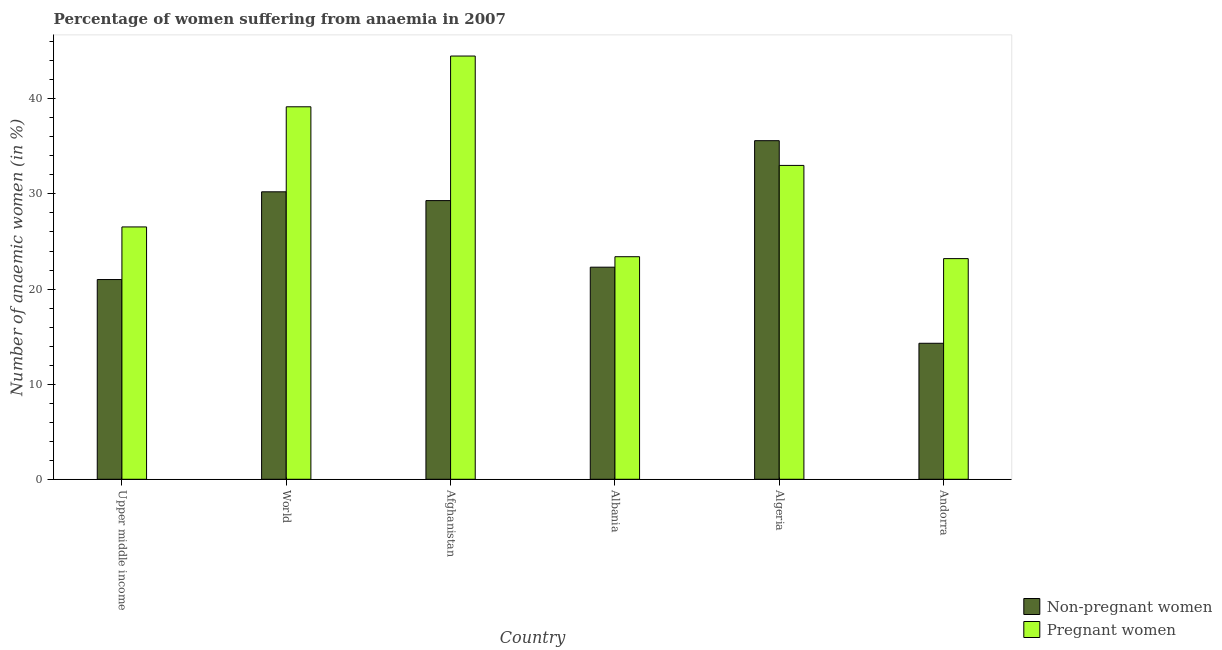How many different coloured bars are there?
Ensure brevity in your answer.  2. How many groups of bars are there?
Keep it short and to the point. 6. How many bars are there on the 4th tick from the right?
Offer a very short reply. 2. What is the label of the 6th group of bars from the left?
Provide a short and direct response. Andorra. What is the percentage of pregnant anaemic women in Afghanistan?
Provide a succinct answer. 44.5. Across all countries, what is the maximum percentage of non-pregnant anaemic women?
Ensure brevity in your answer.  35.6. Across all countries, what is the minimum percentage of non-pregnant anaemic women?
Keep it short and to the point. 14.3. In which country was the percentage of non-pregnant anaemic women maximum?
Your answer should be compact. Algeria. In which country was the percentage of pregnant anaemic women minimum?
Offer a very short reply. Andorra. What is the total percentage of pregnant anaemic women in the graph?
Make the answer very short. 189.8. What is the difference between the percentage of pregnant anaemic women in Afghanistan and that in Andorra?
Your answer should be compact. 21.3. What is the difference between the percentage of non-pregnant anaemic women in Algeria and the percentage of pregnant anaemic women in World?
Offer a terse response. -3.56. What is the average percentage of pregnant anaemic women per country?
Your answer should be very brief. 31.63. In how many countries, is the percentage of pregnant anaemic women greater than 28 %?
Your response must be concise. 3. What is the ratio of the percentage of pregnant anaemic women in Upper middle income to that in World?
Offer a very short reply. 0.68. Is the difference between the percentage of pregnant anaemic women in Andorra and Upper middle income greater than the difference between the percentage of non-pregnant anaemic women in Andorra and Upper middle income?
Offer a terse response. Yes. What is the difference between the highest and the second highest percentage of pregnant anaemic women?
Provide a succinct answer. 5.34. What is the difference between the highest and the lowest percentage of pregnant anaemic women?
Offer a terse response. 21.3. What does the 1st bar from the left in World represents?
Provide a succinct answer. Non-pregnant women. What does the 1st bar from the right in Andorra represents?
Make the answer very short. Pregnant women. How many countries are there in the graph?
Provide a succinct answer. 6. What is the difference between two consecutive major ticks on the Y-axis?
Offer a very short reply. 10. Are the values on the major ticks of Y-axis written in scientific E-notation?
Offer a terse response. No. Does the graph contain any zero values?
Give a very brief answer. No. How many legend labels are there?
Provide a succinct answer. 2. What is the title of the graph?
Offer a terse response. Percentage of women suffering from anaemia in 2007. Does "Methane emissions" appear as one of the legend labels in the graph?
Ensure brevity in your answer.  No. What is the label or title of the X-axis?
Provide a succinct answer. Country. What is the label or title of the Y-axis?
Give a very brief answer. Number of anaemic women (in %). What is the Number of anaemic women (in %) in Non-pregnant women in Upper middle income?
Offer a terse response. 21. What is the Number of anaemic women (in %) of Pregnant women in Upper middle income?
Offer a very short reply. 26.53. What is the Number of anaemic women (in %) in Non-pregnant women in World?
Your response must be concise. 30.22. What is the Number of anaemic women (in %) in Pregnant women in World?
Keep it short and to the point. 39.16. What is the Number of anaemic women (in %) in Non-pregnant women in Afghanistan?
Offer a very short reply. 29.3. What is the Number of anaemic women (in %) of Pregnant women in Afghanistan?
Your answer should be very brief. 44.5. What is the Number of anaemic women (in %) in Non-pregnant women in Albania?
Provide a succinct answer. 22.3. What is the Number of anaemic women (in %) in Pregnant women in Albania?
Your answer should be very brief. 23.4. What is the Number of anaemic women (in %) of Non-pregnant women in Algeria?
Your answer should be compact. 35.6. What is the Number of anaemic women (in %) in Pregnant women in Andorra?
Your answer should be very brief. 23.2. Across all countries, what is the maximum Number of anaemic women (in %) of Non-pregnant women?
Your answer should be very brief. 35.6. Across all countries, what is the maximum Number of anaemic women (in %) in Pregnant women?
Keep it short and to the point. 44.5. Across all countries, what is the minimum Number of anaemic women (in %) of Pregnant women?
Offer a very short reply. 23.2. What is the total Number of anaemic women (in %) in Non-pregnant women in the graph?
Offer a very short reply. 152.72. What is the total Number of anaemic women (in %) in Pregnant women in the graph?
Make the answer very short. 189.8. What is the difference between the Number of anaemic women (in %) in Non-pregnant women in Upper middle income and that in World?
Provide a succinct answer. -9.23. What is the difference between the Number of anaemic women (in %) in Pregnant women in Upper middle income and that in World?
Make the answer very short. -12.63. What is the difference between the Number of anaemic women (in %) in Non-pregnant women in Upper middle income and that in Afghanistan?
Your response must be concise. -8.3. What is the difference between the Number of anaemic women (in %) in Pregnant women in Upper middle income and that in Afghanistan?
Your answer should be very brief. -17.97. What is the difference between the Number of anaemic women (in %) in Non-pregnant women in Upper middle income and that in Albania?
Offer a very short reply. -1.3. What is the difference between the Number of anaemic women (in %) of Pregnant women in Upper middle income and that in Albania?
Offer a very short reply. 3.13. What is the difference between the Number of anaemic women (in %) of Non-pregnant women in Upper middle income and that in Algeria?
Ensure brevity in your answer.  -14.6. What is the difference between the Number of anaemic women (in %) in Pregnant women in Upper middle income and that in Algeria?
Make the answer very short. -6.47. What is the difference between the Number of anaemic women (in %) in Non-pregnant women in Upper middle income and that in Andorra?
Keep it short and to the point. 6.7. What is the difference between the Number of anaemic women (in %) in Pregnant women in Upper middle income and that in Andorra?
Your answer should be very brief. 3.33. What is the difference between the Number of anaemic women (in %) of Non-pregnant women in World and that in Afghanistan?
Offer a very short reply. 0.93. What is the difference between the Number of anaemic women (in %) of Pregnant women in World and that in Afghanistan?
Provide a short and direct response. -5.34. What is the difference between the Number of anaemic women (in %) in Non-pregnant women in World and that in Albania?
Your response must be concise. 7.92. What is the difference between the Number of anaemic women (in %) of Pregnant women in World and that in Albania?
Provide a short and direct response. 15.76. What is the difference between the Number of anaemic women (in %) in Non-pregnant women in World and that in Algeria?
Make the answer very short. -5.38. What is the difference between the Number of anaemic women (in %) in Pregnant women in World and that in Algeria?
Make the answer very short. 6.16. What is the difference between the Number of anaemic women (in %) of Non-pregnant women in World and that in Andorra?
Provide a succinct answer. 15.93. What is the difference between the Number of anaemic women (in %) in Pregnant women in World and that in Andorra?
Give a very brief answer. 15.96. What is the difference between the Number of anaemic women (in %) of Pregnant women in Afghanistan and that in Albania?
Provide a short and direct response. 21.1. What is the difference between the Number of anaemic women (in %) in Non-pregnant women in Afghanistan and that in Algeria?
Provide a short and direct response. -6.3. What is the difference between the Number of anaemic women (in %) of Pregnant women in Afghanistan and that in Andorra?
Your answer should be very brief. 21.3. What is the difference between the Number of anaemic women (in %) of Non-pregnant women in Albania and that in Algeria?
Provide a short and direct response. -13.3. What is the difference between the Number of anaemic women (in %) of Pregnant women in Albania and that in Algeria?
Give a very brief answer. -9.6. What is the difference between the Number of anaemic women (in %) in Non-pregnant women in Albania and that in Andorra?
Make the answer very short. 8. What is the difference between the Number of anaemic women (in %) in Non-pregnant women in Algeria and that in Andorra?
Keep it short and to the point. 21.3. What is the difference between the Number of anaemic women (in %) in Pregnant women in Algeria and that in Andorra?
Offer a terse response. 9.8. What is the difference between the Number of anaemic women (in %) in Non-pregnant women in Upper middle income and the Number of anaemic women (in %) in Pregnant women in World?
Give a very brief answer. -18.16. What is the difference between the Number of anaemic women (in %) in Non-pregnant women in Upper middle income and the Number of anaemic women (in %) in Pregnant women in Afghanistan?
Keep it short and to the point. -23.5. What is the difference between the Number of anaemic women (in %) in Non-pregnant women in Upper middle income and the Number of anaemic women (in %) in Pregnant women in Albania?
Ensure brevity in your answer.  -2.4. What is the difference between the Number of anaemic women (in %) of Non-pregnant women in Upper middle income and the Number of anaemic women (in %) of Pregnant women in Algeria?
Your answer should be compact. -12. What is the difference between the Number of anaemic women (in %) in Non-pregnant women in Upper middle income and the Number of anaemic women (in %) in Pregnant women in Andorra?
Ensure brevity in your answer.  -2.2. What is the difference between the Number of anaemic women (in %) of Non-pregnant women in World and the Number of anaemic women (in %) of Pregnant women in Afghanistan?
Your answer should be very brief. -14.28. What is the difference between the Number of anaemic women (in %) in Non-pregnant women in World and the Number of anaemic women (in %) in Pregnant women in Albania?
Offer a terse response. 6.83. What is the difference between the Number of anaemic women (in %) of Non-pregnant women in World and the Number of anaemic women (in %) of Pregnant women in Algeria?
Give a very brief answer. -2.77. What is the difference between the Number of anaemic women (in %) in Non-pregnant women in World and the Number of anaemic women (in %) in Pregnant women in Andorra?
Provide a succinct answer. 7.03. What is the difference between the Number of anaemic women (in %) of Non-pregnant women in Afghanistan and the Number of anaemic women (in %) of Pregnant women in Algeria?
Offer a terse response. -3.7. What is the difference between the Number of anaemic women (in %) in Non-pregnant women in Albania and the Number of anaemic women (in %) in Pregnant women in Andorra?
Give a very brief answer. -0.9. What is the average Number of anaemic women (in %) of Non-pregnant women per country?
Offer a very short reply. 25.45. What is the average Number of anaemic women (in %) of Pregnant women per country?
Your response must be concise. 31.63. What is the difference between the Number of anaemic women (in %) in Non-pregnant women and Number of anaemic women (in %) in Pregnant women in Upper middle income?
Ensure brevity in your answer.  -5.53. What is the difference between the Number of anaemic women (in %) in Non-pregnant women and Number of anaemic women (in %) in Pregnant women in World?
Provide a short and direct response. -8.94. What is the difference between the Number of anaemic women (in %) of Non-pregnant women and Number of anaemic women (in %) of Pregnant women in Afghanistan?
Your response must be concise. -15.2. What is the ratio of the Number of anaemic women (in %) of Non-pregnant women in Upper middle income to that in World?
Offer a terse response. 0.69. What is the ratio of the Number of anaemic women (in %) of Pregnant women in Upper middle income to that in World?
Provide a short and direct response. 0.68. What is the ratio of the Number of anaemic women (in %) of Non-pregnant women in Upper middle income to that in Afghanistan?
Your response must be concise. 0.72. What is the ratio of the Number of anaemic women (in %) of Pregnant women in Upper middle income to that in Afghanistan?
Ensure brevity in your answer.  0.6. What is the ratio of the Number of anaemic women (in %) in Non-pregnant women in Upper middle income to that in Albania?
Your response must be concise. 0.94. What is the ratio of the Number of anaemic women (in %) in Pregnant women in Upper middle income to that in Albania?
Provide a succinct answer. 1.13. What is the ratio of the Number of anaemic women (in %) of Non-pregnant women in Upper middle income to that in Algeria?
Ensure brevity in your answer.  0.59. What is the ratio of the Number of anaemic women (in %) of Pregnant women in Upper middle income to that in Algeria?
Keep it short and to the point. 0.8. What is the ratio of the Number of anaemic women (in %) of Non-pregnant women in Upper middle income to that in Andorra?
Give a very brief answer. 1.47. What is the ratio of the Number of anaemic women (in %) of Pregnant women in Upper middle income to that in Andorra?
Provide a short and direct response. 1.14. What is the ratio of the Number of anaemic women (in %) of Non-pregnant women in World to that in Afghanistan?
Your response must be concise. 1.03. What is the ratio of the Number of anaemic women (in %) of Pregnant women in World to that in Afghanistan?
Provide a short and direct response. 0.88. What is the ratio of the Number of anaemic women (in %) of Non-pregnant women in World to that in Albania?
Keep it short and to the point. 1.36. What is the ratio of the Number of anaemic women (in %) of Pregnant women in World to that in Albania?
Make the answer very short. 1.67. What is the ratio of the Number of anaemic women (in %) in Non-pregnant women in World to that in Algeria?
Provide a succinct answer. 0.85. What is the ratio of the Number of anaemic women (in %) of Pregnant women in World to that in Algeria?
Your response must be concise. 1.19. What is the ratio of the Number of anaemic women (in %) in Non-pregnant women in World to that in Andorra?
Make the answer very short. 2.11. What is the ratio of the Number of anaemic women (in %) of Pregnant women in World to that in Andorra?
Give a very brief answer. 1.69. What is the ratio of the Number of anaemic women (in %) of Non-pregnant women in Afghanistan to that in Albania?
Make the answer very short. 1.31. What is the ratio of the Number of anaemic women (in %) in Pregnant women in Afghanistan to that in Albania?
Your answer should be very brief. 1.9. What is the ratio of the Number of anaemic women (in %) in Non-pregnant women in Afghanistan to that in Algeria?
Your answer should be compact. 0.82. What is the ratio of the Number of anaemic women (in %) of Pregnant women in Afghanistan to that in Algeria?
Ensure brevity in your answer.  1.35. What is the ratio of the Number of anaemic women (in %) of Non-pregnant women in Afghanistan to that in Andorra?
Offer a terse response. 2.05. What is the ratio of the Number of anaemic women (in %) of Pregnant women in Afghanistan to that in Andorra?
Give a very brief answer. 1.92. What is the ratio of the Number of anaemic women (in %) in Non-pregnant women in Albania to that in Algeria?
Offer a very short reply. 0.63. What is the ratio of the Number of anaemic women (in %) in Pregnant women in Albania to that in Algeria?
Offer a very short reply. 0.71. What is the ratio of the Number of anaemic women (in %) of Non-pregnant women in Albania to that in Andorra?
Offer a terse response. 1.56. What is the ratio of the Number of anaemic women (in %) in Pregnant women in Albania to that in Andorra?
Your answer should be compact. 1.01. What is the ratio of the Number of anaemic women (in %) of Non-pregnant women in Algeria to that in Andorra?
Your answer should be compact. 2.49. What is the ratio of the Number of anaemic women (in %) in Pregnant women in Algeria to that in Andorra?
Ensure brevity in your answer.  1.42. What is the difference between the highest and the second highest Number of anaemic women (in %) of Non-pregnant women?
Provide a succinct answer. 5.38. What is the difference between the highest and the second highest Number of anaemic women (in %) in Pregnant women?
Offer a very short reply. 5.34. What is the difference between the highest and the lowest Number of anaemic women (in %) of Non-pregnant women?
Make the answer very short. 21.3. What is the difference between the highest and the lowest Number of anaemic women (in %) of Pregnant women?
Offer a terse response. 21.3. 